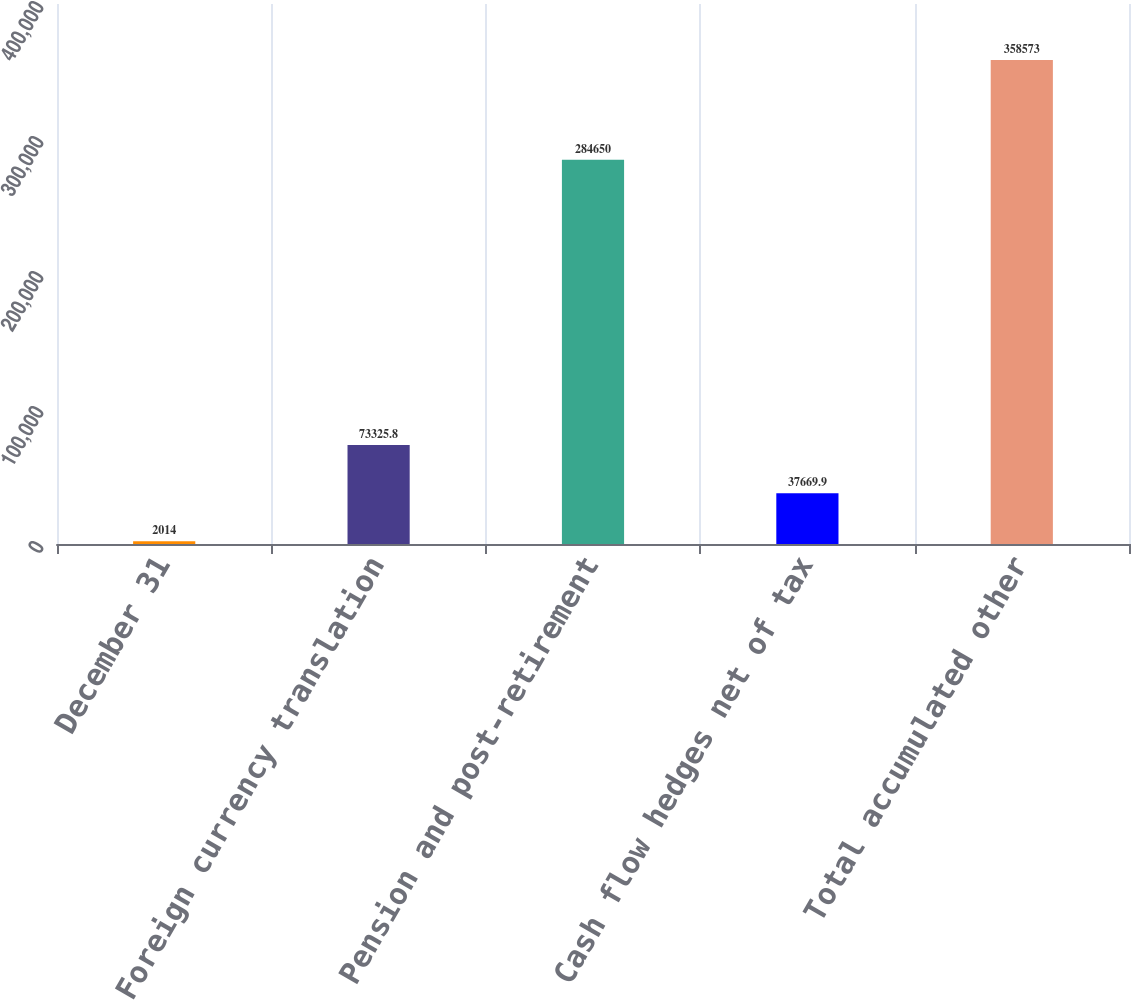Convert chart. <chart><loc_0><loc_0><loc_500><loc_500><bar_chart><fcel>December 31<fcel>Foreign currency translation<fcel>Pension and post-retirement<fcel>Cash flow hedges net of tax<fcel>Total accumulated other<nl><fcel>2014<fcel>73325.8<fcel>284650<fcel>37669.9<fcel>358573<nl></chart> 